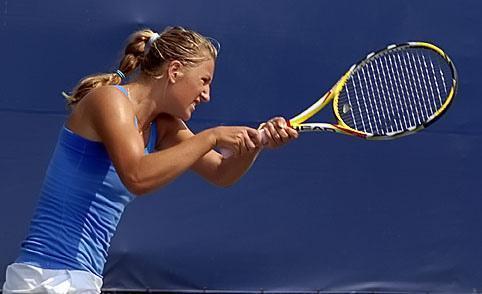How many rackets are there?
Give a very brief answer. 1. How many books are in the picture?
Give a very brief answer. 0. 